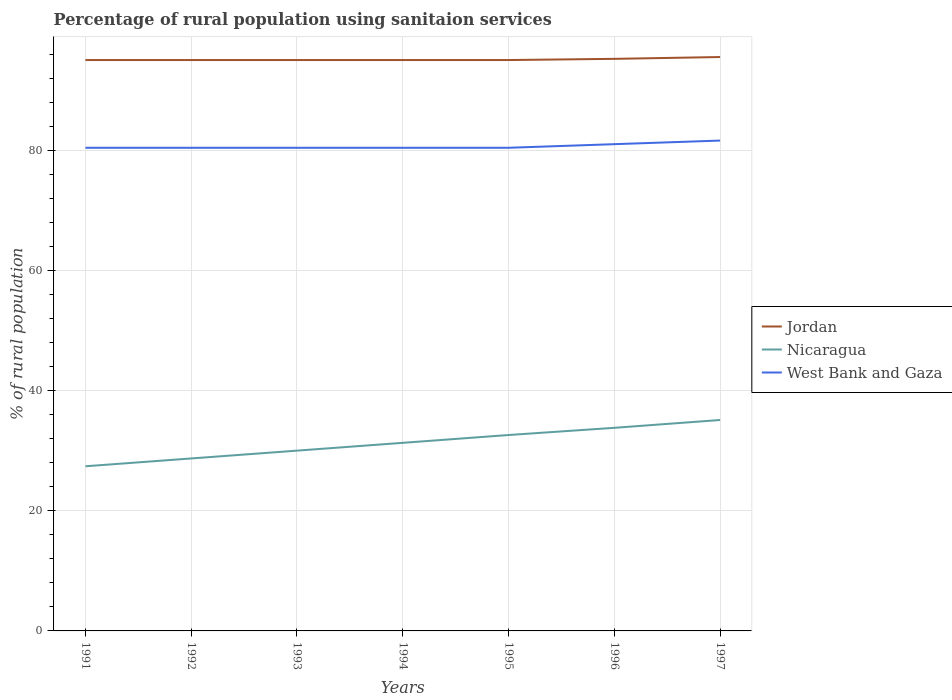Across all years, what is the maximum percentage of rural population using sanitaion services in Nicaragua?
Your response must be concise. 27.4. What is the total percentage of rural population using sanitaion services in Nicaragua in the graph?
Give a very brief answer. -2.5. What is the difference between the highest and the lowest percentage of rural population using sanitaion services in Jordan?
Offer a terse response. 2. Is the percentage of rural population using sanitaion services in Nicaragua strictly greater than the percentage of rural population using sanitaion services in Jordan over the years?
Your response must be concise. Yes. How many lines are there?
Provide a succinct answer. 3. Are the values on the major ticks of Y-axis written in scientific E-notation?
Ensure brevity in your answer.  No. Does the graph contain grids?
Keep it short and to the point. Yes. How many legend labels are there?
Make the answer very short. 3. How are the legend labels stacked?
Give a very brief answer. Vertical. What is the title of the graph?
Offer a very short reply. Percentage of rural population using sanitaion services. Does "Syrian Arab Republic" appear as one of the legend labels in the graph?
Provide a succinct answer. No. What is the label or title of the Y-axis?
Your response must be concise. % of rural population. What is the % of rural population of Jordan in 1991?
Offer a very short reply. 95. What is the % of rural population of Nicaragua in 1991?
Your answer should be compact. 27.4. What is the % of rural population of West Bank and Gaza in 1991?
Give a very brief answer. 80.4. What is the % of rural population of Jordan in 1992?
Your response must be concise. 95. What is the % of rural population of Nicaragua in 1992?
Your answer should be compact. 28.7. What is the % of rural population of West Bank and Gaza in 1992?
Your answer should be compact. 80.4. What is the % of rural population in Nicaragua in 1993?
Give a very brief answer. 30. What is the % of rural population in West Bank and Gaza in 1993?
Provide a succinct answer. 80.4. What is the % of rural population of Nicaragua in 1994?
Provide a short and direct response. 31.3. What is the % of rural population of West Bank and Gaza in 1994?
Your response must be concise. 80.4. What is the % of rural population in Nicaragua in 1995?
Provide a succinct answer. 32.6. What is the % of rural population in West Bank and Gaza in 1995?
Provide a short and direct response. 80.4. What is the % of rural population of Jordan in 1996?
Your response must be concise. 95.2. What is the % of rural population of Nicaragua in 1996?
Your answer should be compact. 33.8. What is the % of rural population of West Bank and Gaza in 1996?
Your answer should be very brief. 81. What is the % of rural population in Jordan in 1997?
Offer a terse response. 95.5. What is the % of rural population in Nicaragua in 1997?
Your answer should be very brief. 35.1. What is the % of rural population in West Bank and Gaza in 1997?
Offer a very short reply. 81.6. Across all years, what is the maximum % of rural population in Jordan?
Your answer should be very brief. 95.5. Across all years, what is the maximum % of rural population of Nicaragua?
Your answer should be compact. 35.1. Across all years, what is the maximum % of rural population of West Bank and Gaza?
Give a very brief answer. 81.6. Across all years, what is the minimum % of rural population in Jordan?
Your answer should be compact. 95. Across all years, what is the minimum % of rural population of Nicaragua?
Keep it short and to the point. 27.4. Across all years, what is the minimum % of rural population of West Bank and Gaza?
Offer a terse response. 80.4. What is the total % of rural population in Jordan in the graph?
Offer a terse response. 665.7. What is the total % of rural population in Nicaragua in the graph?
Provide a short and direct response. 218.9. What is the total % of rural population in West Bank and Gaza in the graph?
Give a very brief answer. 564.6. What is the difference between the % of rural population in Nicaragua in 1991 and that in 1992?
Your response must be concise. -1.3. What is the difference between the % of rural population in Jordan in 1991 and that in 1993?
Offer a very short reply. 0. What is the difference between the % of rural population of Nicaragua in 1991 and that in 1993?
Give a very brief answer. -2.6. What is the difference between the % of rural population of West Bank and Gaza in 1991 and that in 1993?
Keep it short and to the point. 0. What is the difference between the % of rural population of Jordan in 1991 and that in 1994?
Your answer should be very brief. 0. What is the difference between the % of rural population in West Bank and Gaza in 1991 and that in 1994?
Keep it short and to the point. 0. What is the difference between the % of rural population in Nicaragua in 1991 and that in 1995?
Keep it short and to the point. -5.2. What is the difference between the % of rural population in West Bank and Gaza in 1991 and that in 1995?
Offer a terse response. 0. What is the difference between the % of rural population in Jordan in 1991 and that in 1996?
Provide a succinct answer. -0.2. What is the difference between the % of rural population of Jordan in 1992 and that in 1993?
Provide a succinct answer. 0. What is the difference between the % of rural population in Nicaragua in 1992 and that in 1993?
Provide a short and direct response. -1.3. What is the difference between the % of rural population of Jordan in 1992 and that in 1994?
Offer a terse response. 0. What is the difference between the % of rural population of Nicaragua in 1992 and that in 1995?
Give a very brief answer. -3.9. What is the difference between the % of rural population in West Bank and Gaza in 1992 and that in 1995?
Your answer should be compact. 0. What is the difference between the % of rural population in Jordan in 1992 and that in 1996?
Make the answer very short. -0.2. What is the difference between the % of rural population of Nicaragua in 1992 and that in 1996?
Your answer should be very brief. -5.1. What is the difference between the % of rural population in West Bank and Gaza in 1992 and that in 1996?
Keep it short and to the point. -0.6. What is the difference between the % of rural population of Jordan in 1992 and that in 1997?
Make the answer very short. -0.5. What is the difference between the % of rural population in Nicaragua in 1992 and that in 1997?
Ensure brevity in your answer.  -6.4. What is the difference between the % of rural population in Jordan in 1993 and that in 1994?
Your answer should be compact. 0. What is the difference between the % of rural population in Nicaragua in 1993 and that in 1994?
Offer a terse response. -1.3. What is the difference between the % of rural population in West Bank and Gaza in 1993 and that in 1994?
Make the answer very short. 0. What is the difference between the % of rural population of Jordan in 1993 and that in 1996?
Offer a terse response. -0.2. What is the difference between the % of rural population in West Bank and Gaza in 1993 and that in 1996?
Provide a succinct answer. -0.6. What is the difference between the % of rural population in Nicaragua in 1993 and that in 1997?
Your answer should be very brief. -5.1. What is the difference between the % of rural population of West Bank and Gaza in 1993 and that in 1997?
Your answer should be very brief. -1.2. What is the difference between the % of rural population of Jordan in 1994 and that in 1995?
Your answer should be very brief. 0. What is the difference between the % of rural population of Nicaragua in 1994 and that in 1995?
Offer a terse response. -1.3. What is the difference between the % of rural population of West Bank and Gaza in 1994 and that in 1997?
Ensure brevity in your answer.  -1.2. What is the difference between the % of rural population of Nicaragua in 1995 and that in 1997?
Offer a very short reply. -2.5. What is the difference between the % of rural population in West Bank and Gaza in 1995 and that in 1997?
Offer a very short reply. -1.2. What is the difference between the % of rural population of West Bank and Gaza in 1996 and that in 1997?
Provide a short and direct response. -0.6. What is the difference between the % of rural population in Jordan in 1991 and the % of rural population in Nicaragua in 1992?
Offer a terse response. 66.3. What is the difference between the % of rural population of Nicaragua in 1991 and the % of rural population of West Bank and Gaza in 1992?
Ensure brevity in your answer.  -53. What is the difference between the % of rural population of Jordan in 1991 and the % of rural population of Nicaragua in 1993?
Keep it short and to the point. 65. What is the difference between the % of rural population in Jordan in 1991 and the % of rural population in West Bank and Gaza in 1993?
Ensure brevity in your answer.  14.6. What is the difference between the % of rural population of Nicaragua in 1991 and the % of rural population of West Bank and Gaza in 1993?
Your answer should be very brief. -53. What is the difference between the % of rural population in Jordan in 1991 and the % of rural population in Nicaragua in 1994?
Give a very brief answer. 63.7. What is the difference between the % of rural population of Nicaragua in 1991 and the % of rural population of West Bank and Gaza in 1994?
Your response must be concise. -53. What is the difference between the % of rural population in Jordan in 1991 and the % of rural population in Nicaragua in 1995?
Your answer should be compact. 62.4. What is the difference between the % of rural population of Jordan in 1991 and the % of rural population of West Bank and Gaza in 1995?
Provide a short and direct response. 14.6. What is the difference between the % of rural population in Nicaragua in 1991 and the % of rural population in West Bank and Gaza in 1995?
Your answer should be very brief. -53. What is the difference between the % of rural population of Jordan in 1991 and the % of rural population of Nicaragua in 1996?
Provide a succinct answer. 61.2. What is the difference between the % of rural population in Jordan in 1991 and the % of rural population in West Bank and Gaza in 1996?
Ensure brevity in your answer.  14. What is the difference between the % of rural population of Nicaragua in 1991 and the % of rural population of West Bank and Gaza in 1996?
Provide a succinct answer. -53.6. What is the difference between the % of rural population in Jordan in 1991 and the % of rural population in Nicaragua in 1997?
Make the answer very short. 59.9. What is the difference between the % of rural population in Jordan in 1991 and the % of rural population in West Bank and Gaza in 1997?
Ensure brevity in your answer.  13.4. What is the difference between the % of rural population in Nicaragua in 1991 and the % of rural population in West Bank and Gaza in 1997?
Make the answer very short. -54.2. What is the difference between the % of rural population of Nicaragua in 1992 and the % of rural population of West Bank and Gaza in 1993?
Keep it short and to the point. -51.7. What is the difference between the % of rural population of Jordan in 1992 and the % of rural population of Nicaragua in 1994?
Offer a very short reply. 63.7. What is the difference between the % of rural population of Jordan in 1992 and the % of rural population of West Bank and Gaza in 1994?
Provide a succinct answer. 14.6. What is the difference between the % of rural population in Nicaragua in 1992 and the % of rural population in West Bank and Gaza in 1994?
Give a very brief answer. -51.7. What is the difference between the % of rural population in Jordan in 1992 and the % of rural population in Nicaragua in 1995?
Ensure brevity in your answer.  62.4. What is the difference between the % of rural population of Jordan in 1992 and the % of rural population of West Bank and Gaza in 1995?
Keep it short and to the point. 14.6. What is the difference between the % of rural population in Nicaragua in 1992 and the % of rural population in West Bank and Gaza in 1995?
Keep it short and to the point. -51.7. What is the difference between the % of rural population of Jordan in 1992 and the % of rural population of Nicaragua in 1996?
Offer a very short reply. 61.2. What is the difference between the % of rural population of Jordan in 1992 and the % of rural population of West Bank and Gaza in 1996?
Keep it short and to the point. 14. What is the difference between the % of rural population in Nicaragua in 1992 and the % of rural population in West Bank and Gaza in 1996?
Offer a very short reply. -52.3. What is the difference between the % of rural population of Jordan in 1992 and the % of rural population of Nicaragua in 1997?
Make the answer very short. 59.9. What is the difference between the % of rural population of Jordan in 1992 and the % of rural population of West Bank and Gaza in 1997?
Give a very brief answer. 13.4. What is the difference between the % of rural population of Nicaragua in 1992 and the % of rural population of West Bank and Gaza in 1997?
Make the answer very short. -52.9. What is the difference between the % of rural population in Jordan in 1993 and the % of rural population in Nicaragua in 1994?
Ensure brevity in your answer.  63.7. What is the difference between the % of rural population of Nicaragua in 1993 and the % of rural population of West Bank and Gaza in 1994?
Provide a succinct answer. -50.4. What is the difference between the % of rural population in Jordan in 1993 and the % of rural population in Nicaragua in 1995?
Your response must be concise. 62.4. What is the difference between the % of rural population in Jordan in 1993 and the % of rural population in West Bank and Gaza in 1995?
Your answer should be very brief. 14.6. What is the difference between the % of rural population of Nicaragua in 1993 and the % of rural population of West Bank and Gaza in 1995?
Your answer should be very brief. -50.4. What is the difference between the % of rural population of Jordan in 1993 and the % of rural population of Nicaragua in 1996?
Ensure brevity in your answer.  61.2. What is the difference between the % of rural population in Jordan in 1993 and the % of rural population in West Bank and Gaza in 1996?
Make the answer very short. 14. What is the difference between the % of rural population in Nicaragua in 1993 and the % of rural population in West Bank and Gaza in 1996?
Your response must be concise. -51. What is the difference between the % of rural population in Jordan in 1993 and the % of rural population in Nicaragua in 1997?
Make the answer very short. 59.9. What is the difference between the % of rural population of Nicaragua in 1993 and the % of rural population of West Bank and Gaza in 1997?
Offer a terse response. -51.6. What is the difference between the % of rural population of Jordan in 1994 and the % of rural population of Nicaragua in 1995?
Make the answer very short. 62.4. What is the difference between the % of rural population in Nicaragua in 1994 and the % of rural population in West Bank and Gaza in 1995?
Provide a short and direct response. -49.1. What is the difference between the % of rural population in Jordan in 1994 and the % of rural population in Nicaragua in 1996?
Give a very brief answer. 61.2. What is the difference between the % of rural population of Jordan in 1994 and the % of rural population of West Bank and Gaza in 1996?
Your response must be concise. 14. What is the difference between the % of rural population of Nicaragua in 1994 and the % of rural population of West Bank and Gaza in 1996?
Provide a short and direct response. -49.7. What is the difference between the % of rural population in Jordan in 1994 and the % of rural population in Nicaragua in 1997?
Make the answer very short. 59.9. What is the difference between the % of rural population of Nicaragua in 1994 and the % of rural population of West Bank and Gaza in 1997?
Your answer should be very brief. -50.3. What is the difference between the % of rural population in Jordan in 1995 and the % of rural population in Nicaragua in 1996?
Your answer should be compact. 61.2. What is the difference between the % of rural population of Nicaragua in 1995 and the % of rural population of West Bank and Gaza in 1996?
Offer a very short reply. -48.4. What is the difference between the % of rural population in Jordan in 1995 and the % of rural population in Nicaragua in 1997?
Your response must be concise. 59.9. What is the difference between the % of rural population in Jordan in 1995 and the % of rural population in West Bank and Gaza in 1997?
Offer a terse response. 13.4. What is the difference between the % of rural population of Nicaragua in 1995 and the % of rural population of West Bank and Gaza in 1997?
Provide a succinct answer. -49. What is the difference between the % of rural population of Jordan in 1996 and the % of rural population of Nicaragua in 1997?
Give a very brief answer. 60.1. What is the difference between the % of rural population of Jordan in 1996 and the % of rural population of West Bank and Gaza in 1997?
Provide a short and direct response. 13.6. What is the difference between the % of rural population of Nicaragua in 1996 and the % of rural population of West Bank and Gaza in 1997?
Keep it short and to the point. -47.8. What is the average % of rural population in Jordan per year?
Offer a terse response. 95.1. What is the average % of rural population in Nicaragua per year?
Give a very brief answer. 31.27. What is the average % of rural population in West Bank and Gaza per year?
Your answer should be very brief. 80.66. In the year 1991, what is the difference between the % of rural population in Jordan and % of rural population in Nicaragua?
Provide a succinct answer. 67.6. In the year 1991, what is the difference between the % of rural population in Nicaragua and % of rural population in West Bank and Gaza?
Ensure brevity in your answer.  -53. In the year 1992, what is the difference between the % of rural population in Jordan and % of rural population in Nicaragua?
Provide a succinct answer. 66.3. In the year 1992, what is the difference between the % of rural population in Jordan and % of rural population in West Bank and Gaza?
Give a very brief answer. 14.6. In the year 1992, what is the difference between the % of rural population of Nicaragua and % of rural population of West Bank and Gaza?
Your answer should be very brief. -51.7. In the year 1993, what is the difference between the % of rural population in Jordan and % of rural population in West Bank and Gaza?
Your answer should be compact. 14.6. In the year 1993, what is the difference between the % of rural population of Nicaragua and % of rural population of West Bank and Gaza?
Offer a very short reply. -50.4. In the year 1994, what is the difference between the % of rural population of Jordan and % of rural population of Nicaragua?
Offer a terse response. 63.7. In the year 1994, what is the difference between the % of rural population of Jordan and % of rural population of West Bank and Gaza?
Keep it short and to the point. 14.6. In the year 1994, what is the difference between the % of rural population in Nicaragua and % of rural population in West Bank and Gaza?
Your response must be concise. -49.1. In the year 1995, what is the difference between the % of rural population of Jordan and % of rural population of Nicaragua?
Keep it short and to the point. 62.4. In the year 1995, what is the difference between the % of rural population of Jordan and % of rural population of West Bank and Gaza?
Your answer should be very brief. 14.6. In the year 1995, what is the difference between the % of rural population of Nicaragua and % of rural population of West Bank and Gaza?
Keep it short and to the point. -47.8. In the year 1996, what is the difference between the % of rural population of Jordan and % of rural population of Nicaragua?
Keep it short and to the point. 61.4. In the year 1996, what is the difference between the % of rural population of Nicaragua and % of rural population of West Bank and Gaza?
Your answer should be very brief. -47.2. In the year 1997, what is the difference between the % of rural population in Jordan and % of rural population in Nicaragua?
Keep it short and to the point. 60.4. In the year 1997, what is the difference between the % of rural population in Jordan and % of rural population in West Bank and Gaza?
Keep it short and to the point. 13.9. In the year 1997, what is the difference between the % of rural population in Nicaragua and % of rural population in West Bank and Gaza?
Offer a terse response. -46.5. What is the ratio of the % of rural population in Nicaragua in 1991 to that in 1992?
Your answer should be compact. 0.95. What is the ratio of the % of rural population of Jordan in 1991 to that in 1993?
Ensure brevity in your answer.  1. What is the ratio of the % of rural population in Nicaragua in 1991 to that in 1993?
Offer a terse response. 0.91. What is the ratio of the % of rural population in West Bank and Gaza in 1991 to that in 1993?
Your response must be concise. 1. What is the ratio of the % of rural population in Nicaragua in 1991 to that in 1994?
Provide a short and direct response. 0.88. What is the ratio of the % of rural population of Jordan in 1991 to that in 1995?
Offer a terse response. 1. What is the ratio of the % of rural population in Nicaragua in 1991 to that in 1995?
Your response must be concise. 0.84. What is the ratio of the % of rural population of Jordan in 1991 to that in 1996?
Provide a succinct answer. 1. What is the ratio of the % of rural population of Nicaragua in 1991 to that in 1996?
Your answer should be very brief. 0.81. What is the ratio of the % of rural population of West Bank and Gaza in 1991 to that in 1996?
Offer a very short reply. 0.99. What is the ratio of the % of rural population in Nicaragua in 1991 to that in 1997?
Offer a very short reply. 0.78. What is the ratio of the % of rural population of West Bank and Gaza in 1991 to that in 1997?
Your answer should be very brief. 0.99. What is the ratio of the % of rural population in Jordan in 1992 to that in 1993?
Give a very brief answer. 1. What is the ratio of the % of rural population in Nicaragua in 1992 to that in 1993?
Ensure brevity in your answer.  0.96. What is the ratio of the % of rural population in Nicaragua in 1992 to that in 1994?
Ensure brevity in your answer.  0.92. What is the ratio of the % of rural population of West Bank and Gaza in 1992 to that in 1994?
Offer a very short reply. 1. What is the ratio of the % of rural population in Nicaragua in 1992 to that in 1995?
Provide a succinct answer. 0.88. What is the ratio of the % of rural population of Nicaragua in 1992 to that in 1996?
Offer a very short reply. 0.85. What is the ratio of the % of rural population of West Bank and Gaza in 1992 to that in 1996?
Your response must be concise. 0.99. What is the ratio of the % of rural population of Jordan in 1992 to that in 1997?
Offer a terse response. 0.99. What is the ratio of the % of rural population of Nicaragua in 1992 to that in 1997?
Make the answer very short. 0.82. What is the ratio of the % of rural population of West Bank and Gaza in 1992 to that in 1997?
Provide a short and direct response. 0.99. What is the ratio of the % of rural population of Nicaragua in 1993 to that in 1994?
Your answer should be very brief. 0.96. What is the ratio of the % of rural population of West Bank and Gaza in 1993 to that in 1994?
Ensure brevity in your answer.  1. What is the ratio of the % of rural population of Nicaragua in 1993 to that in 1995?
Provide a short and direct response. 0.92. What is the ratio of the % of rural population in West Bank and Gaza in 1993 to that in 1995?
Keep it short and to the point. 1. What is the ratio of the % of rural population in Jordan in 1993 to that in 1996?
Make the answer very short. 1. What is the ratio of the % of rural population of Nicaragua in 1993 to that in 1996?
Provide a succinct answer. 0.89. What is the ratio of the % of rural population in West Bank and Gaza in 1993 to that in 1996?
Provide a succinct answer. 0.99. What is the ratio of the % of rural population in Jordan in 1993 to that in 1997?
Ensure brevity in your answer.  0.99. What is the ratio of the % of rural population in Nicaragua in 1993 to that in 1997?
Keep it short and to the point. 0.85. What is the ratio of the % of rural population in Jordan in 1994 to that in 1995?
Your answer should be very brief. 1. What is the ratio of the % of rural population of Nicaragua in 1994 to that in 1995?
Keep it short and to the point. 0.96. What is the ratio of the % of rural population of Jordan in 1994 to that in 1996?
Provide a short and direct response. 1. What is the ratio of the % of rural population of Nicaragua in 1994 to that in 1996?
Your response must be concise. 0.93. What is the ratio of the % of rural population of Jordan in 1994 to that in 1997?
Offer a terse response. 0.99. What is the ratio of the % of rural population of Nicaragua in 1994 to that in 1997?
Provide a short and direct response. 0.89. What is the ratio of the % of rural population of Jordan in 1995 to that in 1996?
Make the answer very short. 1. What is the ratio of the % of rural population in Nicaragua in 1995 to that in 1996?
Provide a short and direct response. 0.96. What is the ratio of the % of rural population of Nicaragua in 1995 to that in 1997?
Ensure brevity in your answer.  0.93. What is the ratio of the % of rural population of West Bank and Gaza in 1995 to that in 1997?
Ensure brevity in your answer.  0.99. What is the ratio of the % of rural population in Nicaragua in 1996 to that in 1997?
Keep it short and to the point. 0.96. What is the difference between the highest and the lowest % of rural population in Jordan?
Make the answer very short. 0.5. What is the difference between the highest and the lowest % of rural population of Nicaragua?
Your answer should be compact. 7.7. 